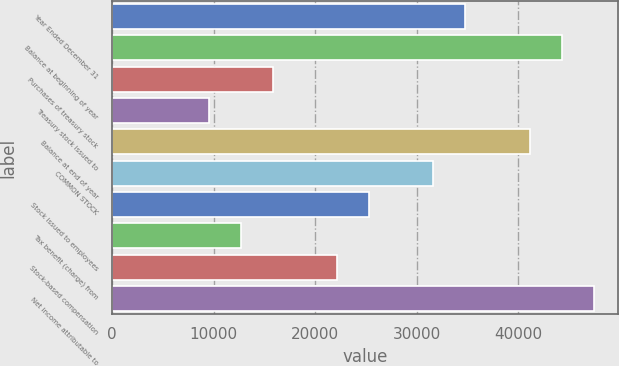Convert chart. <chart><loc_0><loc_0><loc_500><loc_500><bar_chart><fcel>Year Ended December 31<fcel>Balance at beginning of year<fcel>Purchases of treasury stock<fcel>Treasury stock issued to<fcel>Balance at end of year<fcel>COMMON STOCK<fcel>Stock issued to employees<fcel>Tax benefit (charge) from<fcel>Stock-based compensation<fcel>Net income attributable to<nl><fcel>34794.7<fcel>44273.8<fcel>15836.5<fcel>9517.1<fcel>41114.1<fcel>31635<fcel>25315.6<fcel>12676.8<fcel>22155.9<fcel>47433.5<nl></chart> 